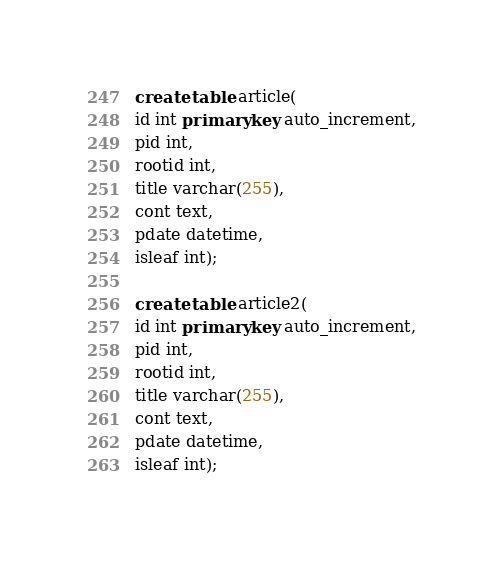Convert code to text. <code><loc_0><loc_0><loc_500><loc_500><_SQL_>create table article(
id int primary key auto_increment,
pid int,
rootid int,
title varchar(255),
cont text,
pdate datetime,
isleaf int);

create table article2(
id int primary key auto_increment,
pid int,
rootid int,
title varchar(255),
cont text,
pdate datetime,
isleaf int);
</code> 